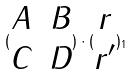<formula> <loc_0><loc_0><loc_500><loc_500>( \begin{matrix} A & B \\ C & D \\ \end{matrix} ) \cdot ( \begin{matrix} r \\ r ^ { \prime } \\ \end{matrix} ) _ { 1 }</formula> 